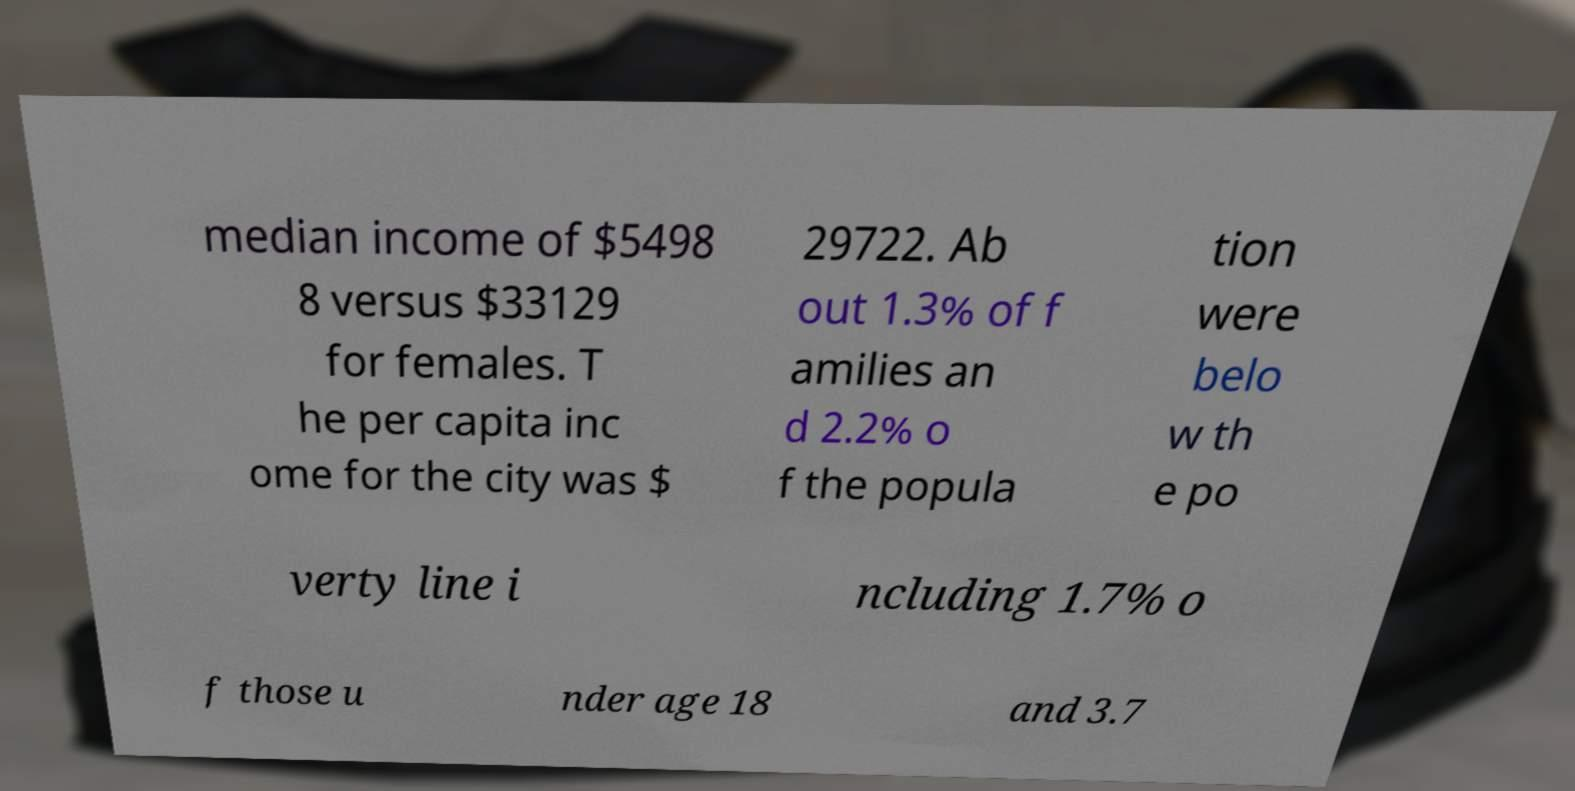Could you extract and type out the text from this image? median income of $5498 8 versus $33129 for females. T he per capita inc ome for the city was $ 29722. Ab out 1.3% of f amilies an d 2.2% o f the popula tion were belo w th e po verty line i ncluding 1.7% o f those u nder age 18 and 3.7 